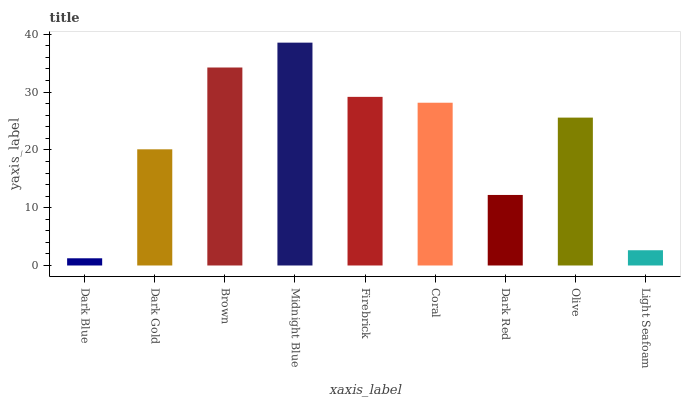Is Dark Gold the minimum?
Answer yes or no. No. Is Dark Gold the maximum?
Answer yes or no. No. Is Dark Gold greater than Dark Blue?
Answer yes or no. Yes. Is Dark Blue less than Dark Gold?
Answer yes or no. Yes. Is Dark Blue greater than Dark Gold?
Answer yes or no. No. Is Dark Gold less than Dark Blue?
Answer yes or no. No. Is Olive the high median?
Answer yes or no. Yes. Is Olive the low median?
Answer yes or no. Yes. Is Midnight Blue the high median?
Answer yes or no. No. Is Coral the low median?
Answer yes or no. No. 